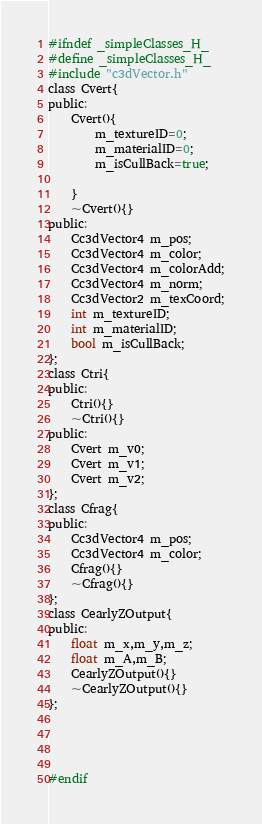<code> <loc_0><loc_0><loc_500><loc_500><_C_>#ifndef _simpleClasses_H_
#define _simpleClasses_H_
#include "c3dVector.h"
class Cvert{
public:
	Cvert(){
		m_textureID=0;
		m_materialID=0;
		m_isCullBack=true;
		
	}
	~Cvert(){}
public:
	Cc3dVector4 m_pos;
	Cc3dVector4 m_color;
	Cc3dVector4 m_colorAdd;
	Cc3dVector4 m_norm;
	Cc3dVector2 m_texCoord;
	int m_textureID;
	int m_materialID;
	bool m_isCullBack;
};
class Ctri{
public:
	Ctri(){}
	~Ctri(){}
public:
	Cvert m_v0;
	Cvert m_v1;
	Cvert m_v2;
};
class Cfrag{
public:
	Cc3dVector4 m_pos;
	Cc3dVector4 m_color;
	Cfrag(){}
	~Cfrag(){}
};
class CearlyZOutput{
public:
	float m_x,m_y,m_z;
	float m_A,m_B;
	CearlyZOutput(){}
	~CearlyZOutput(){}
};




#endif</code> 